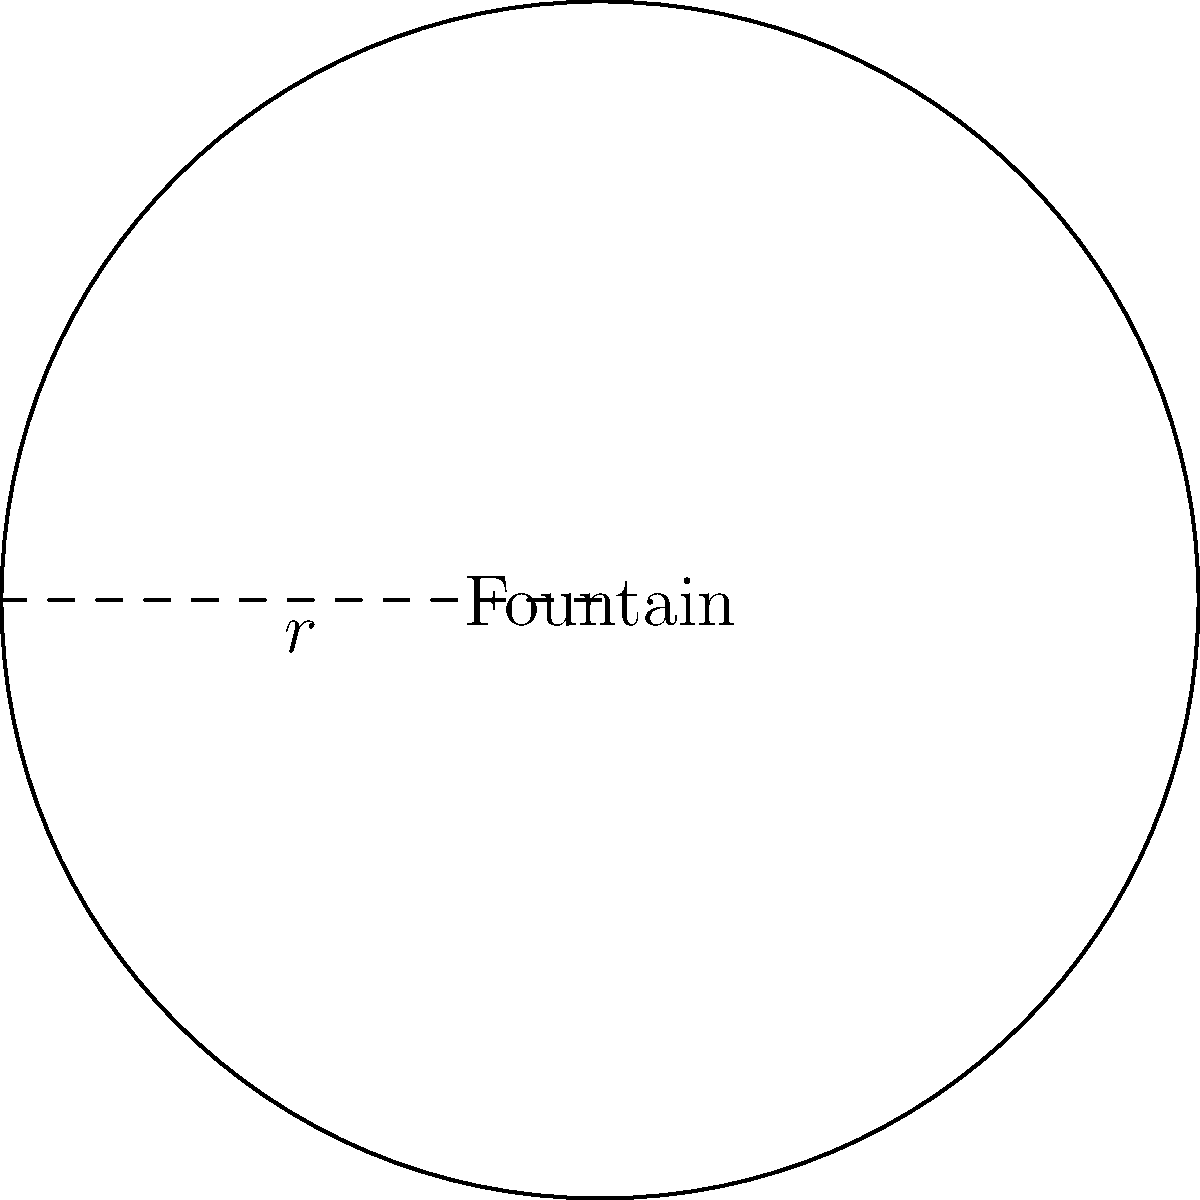In Amagertorv, one of Copenhagen's historic squares, there is a circular fountain. If the radius of this fountain is 3 meters, what is its circumference? To find the circumference of a circular fountain, we need to use the formula for the circumference of a circle:

$$C = 2\pi r$$

Where:
$C$ = circumference
$\pi$ = pi (approximately 3.14159)
$r$ = radius

Given:
$r = 3$ meters

Step 1: Substitute the known values into the formula.
$$C = 2\pi (3)$$

Step 2: Multiply.
$$C = 6\pi$$

Step 3: Calculate the final value (using 3.14159 for π).
$$C \approx 6 \times 3.14159 = 18.84954 \text{ meters}$$

Therefore, the circumference of the fountain is approximately 18.85 meters.
Answer: $18.85 \text{ meters}$ 